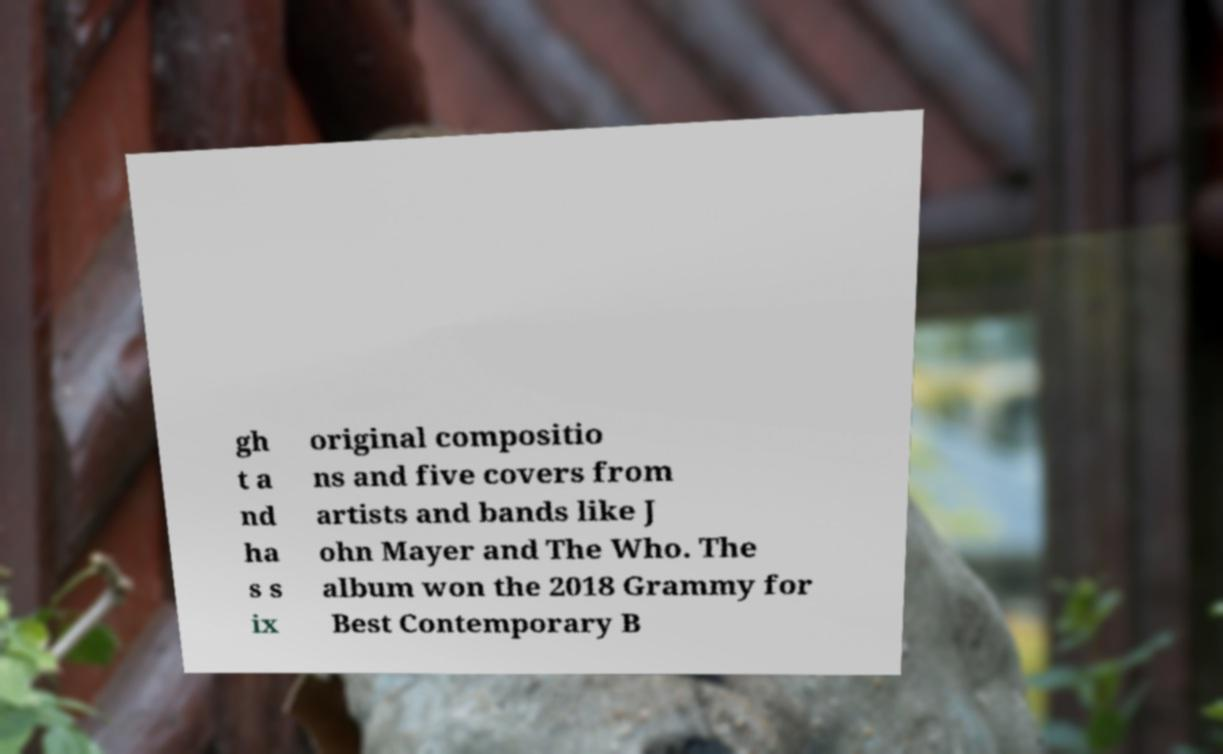There's text embedded in this image that I need extracted. Can you transcribe it verbatim? gh t a nd ha s s ix original compositio ns and five covers from artists and bands like J ohn Mayer and The Who. The album won the 2018 Grammy for Best Contemporary B 